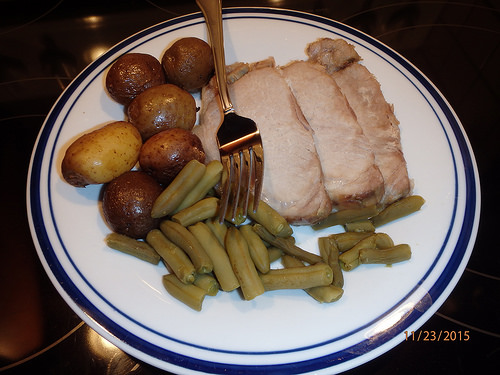<image>
Is there a fork in the dinner? Yes. The fork is contained within or inside the dinner, showing a containment relationship. Is the potato next to the meat? No. The potato is not positioned next to the meat. They are located in different areas of the scene. 